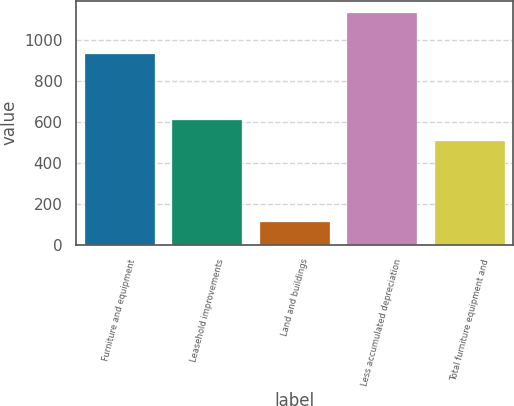Convert chart to OTSL. <chart><loc_0><loc_0><loc_500><loc_500><bar_chart><fcel>Furniture and equipment<fcel>Leasehold improvements<fcel>Land and buildings<fcel>Less accumulated depreciation<fcel>Total furniture equipment and<nl><fcel>932.6<fcel>607.3<fcel>109.9<fcel>1134.9<fcel>504.8<nl></chart> 